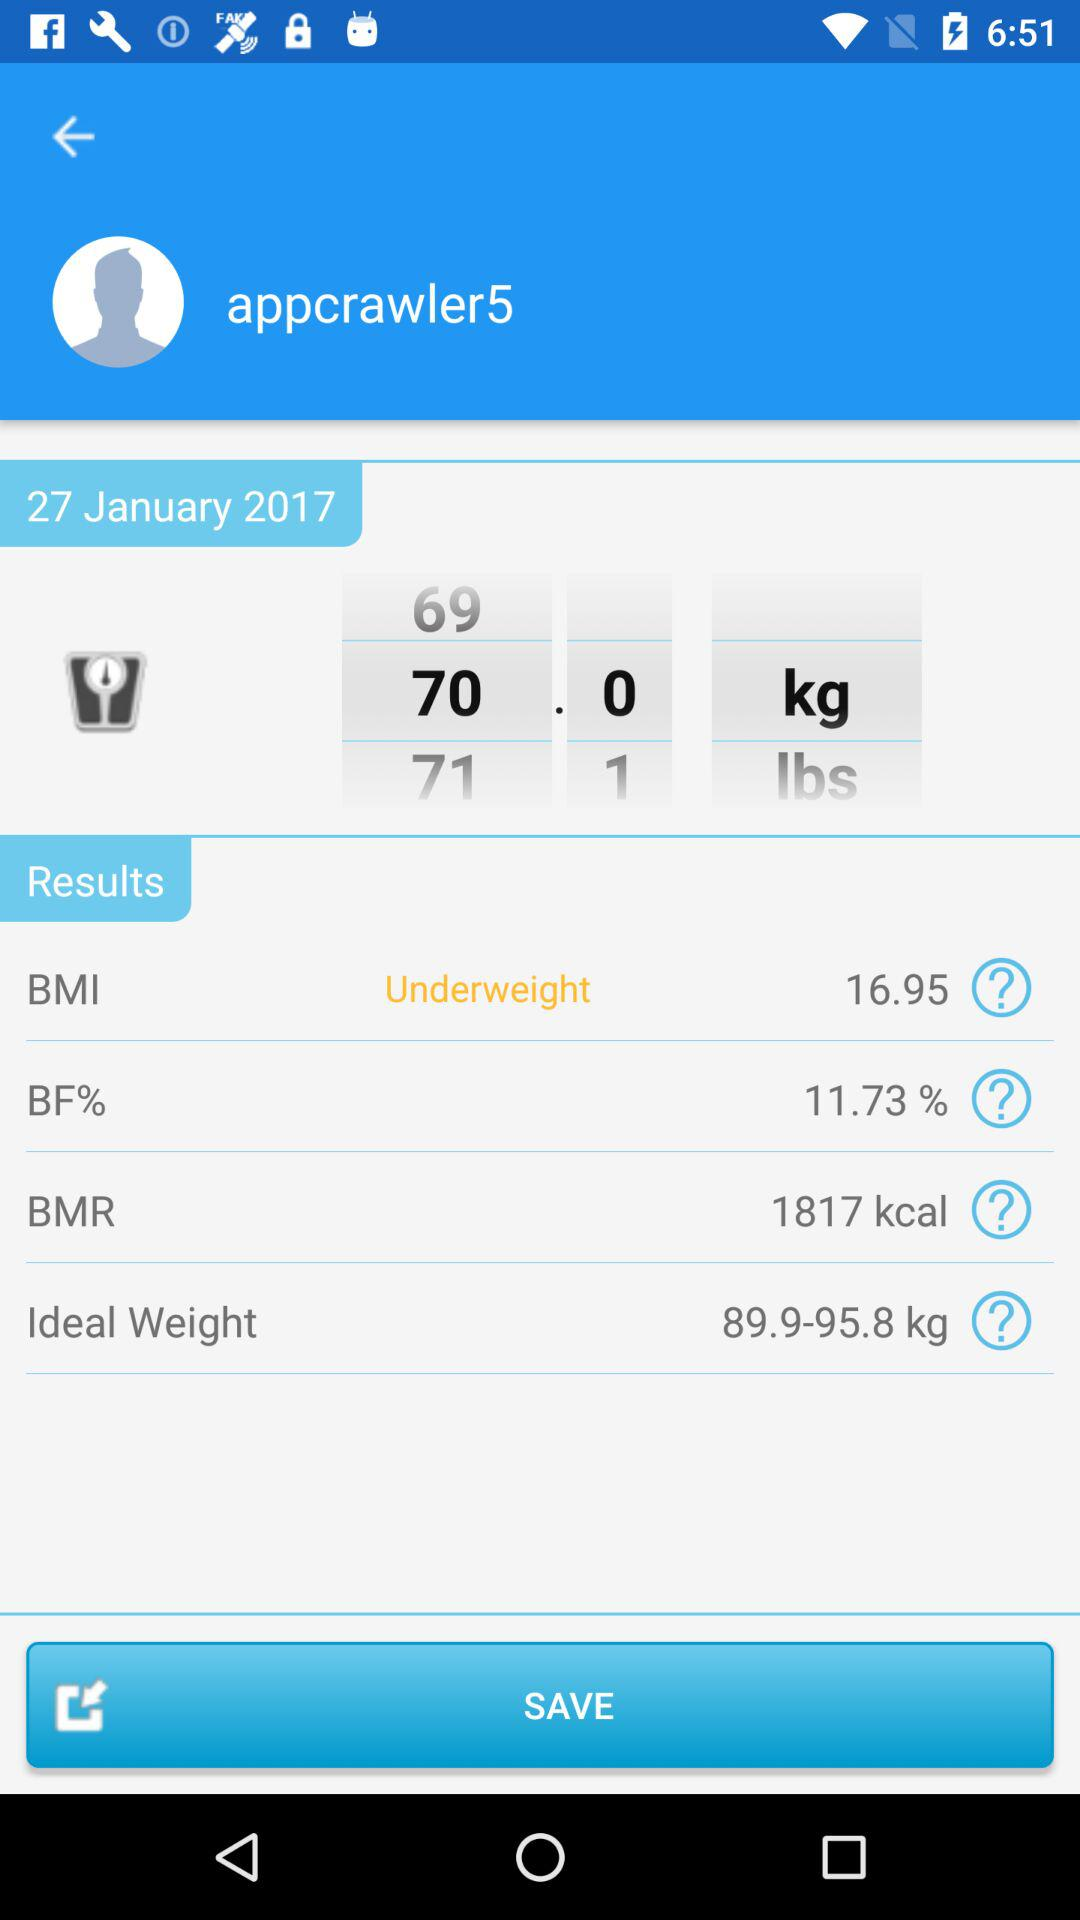What is the BMR? The BMR is 1817 kcal. 